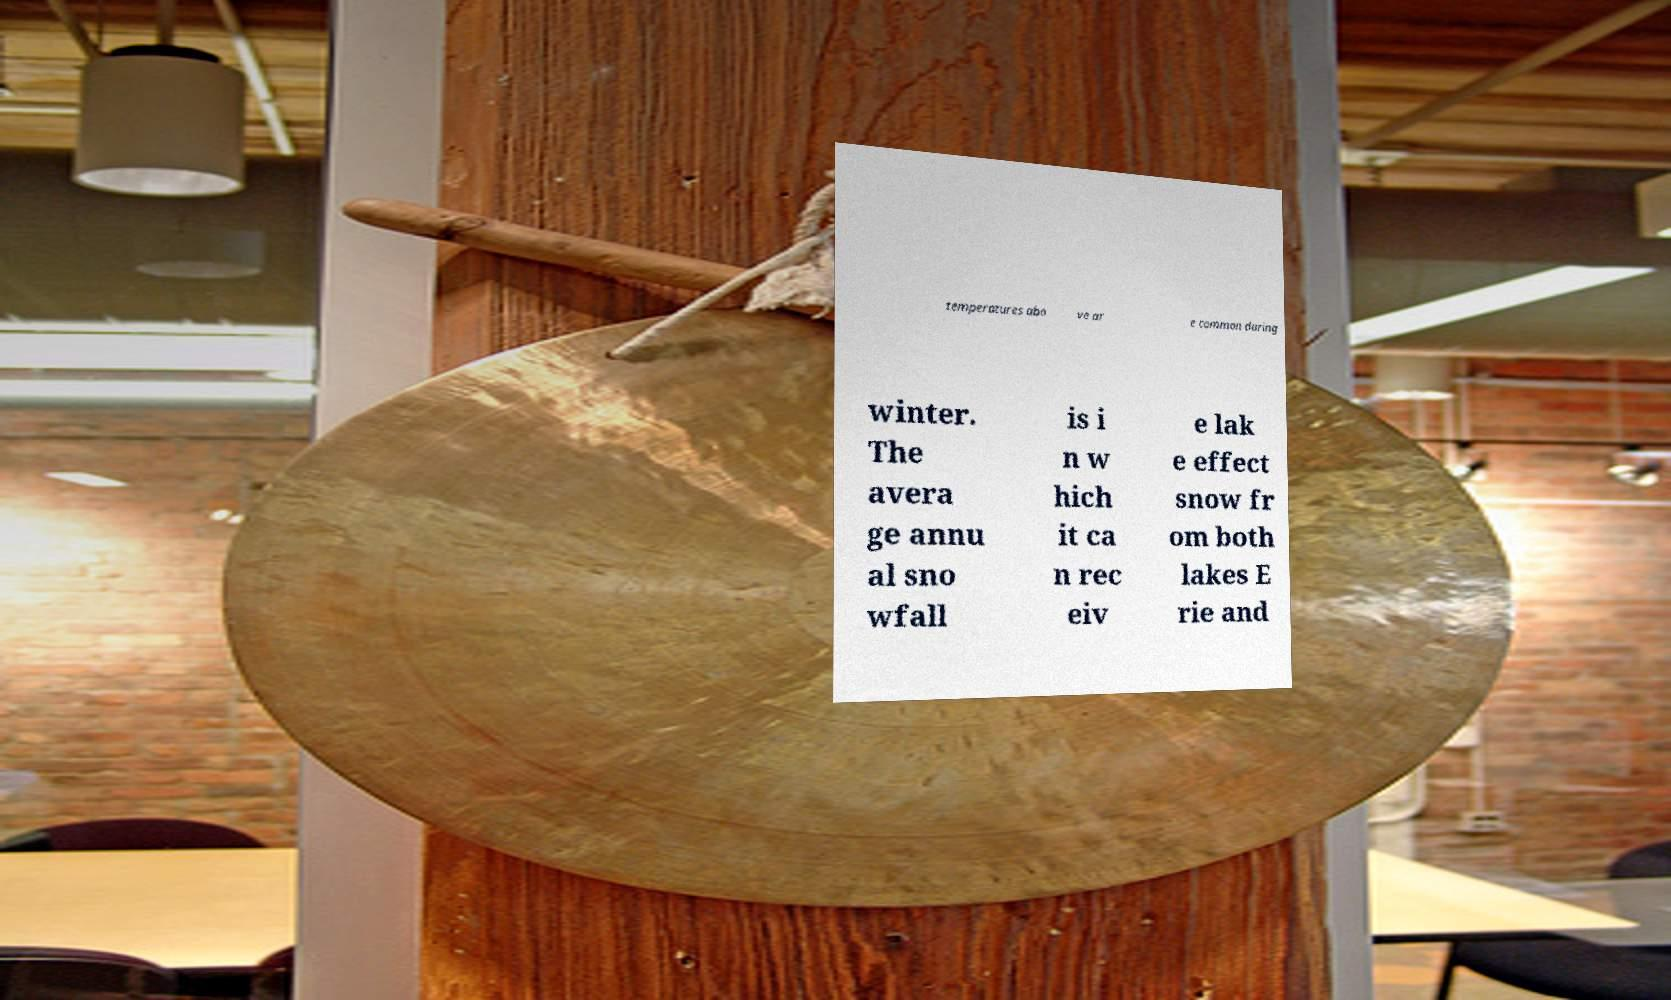There's text embedded in this image that I need extracted. Can you transcribe it verbatim? temperatures abo ve ar e common during winter. The avera ge annu al sno wfall is i n w hich it ca n rec eiv e lak e effect snow fr om both lakes E rie and 